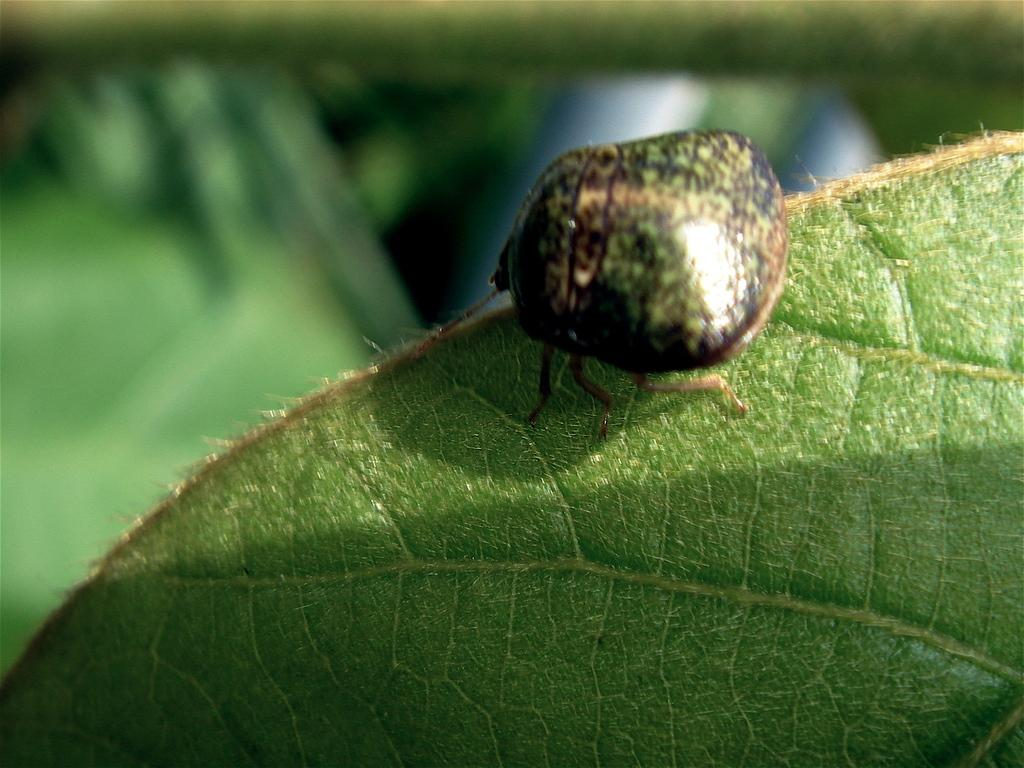What type of plant material is present in the image? There is a green leaf in the image. Is there any living organism on the leaf? Yes, there is an insect on the leaf. What type of print can be seen on the leaf in the image? There is no print visible on the leaf in the image. How many pigs are present on the leaf in the image? There are no pigs present on the leaf in the image. 